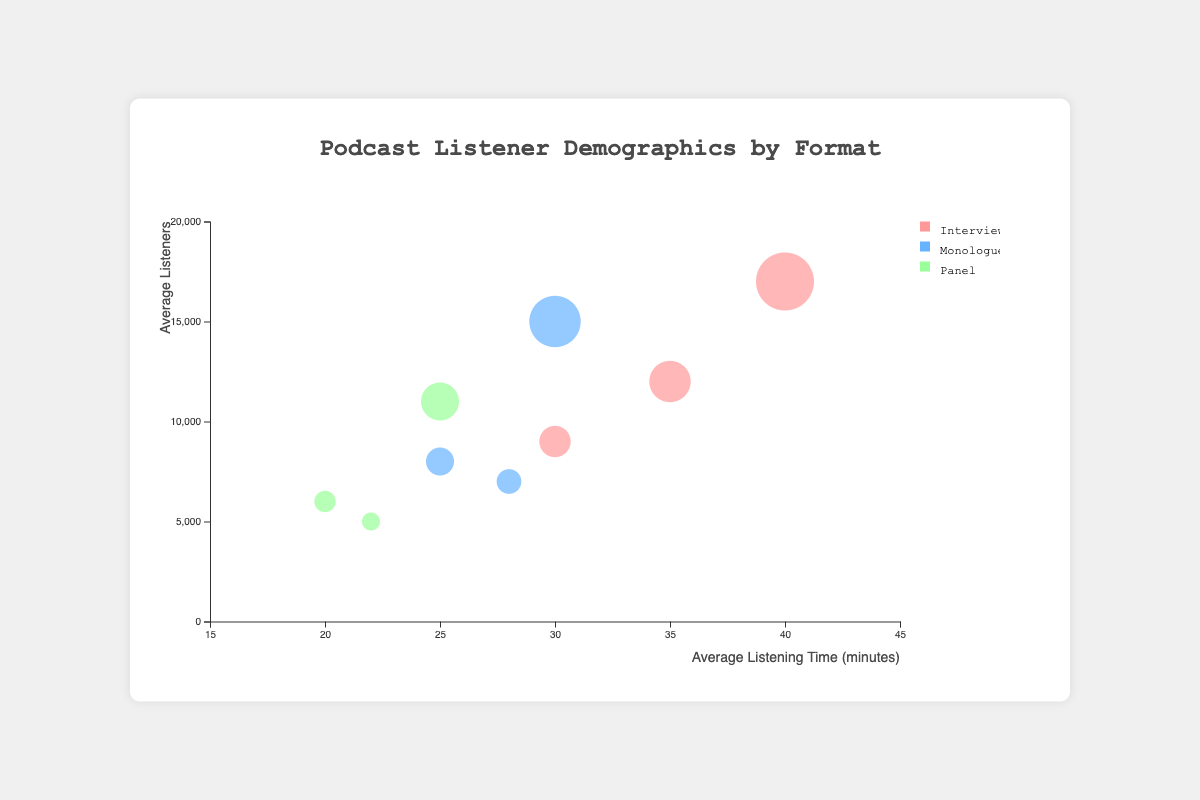What is the title of the chart? The title is displayed at the top of the chart, which reads "Podcast Listener Demographics by Format".
Answer: Podcast Listener Demographics by Format What does the y-axis represent? The y-axis represents the "Average Listeners", as indicated by the label beside the axis.
Answer: Average Listeners Which podcast format has the highest average listeners in the 25-34 age group? By looking at the bubbles for the 25-34 age group, the bubble for "Interview" format is the largest in size and furthest up on the y-axis, indicating it has the highest average listeners.
Answer: Interview What is the average listening time for the Monologue format for the 18-24 age group? Locate the bubble for the Monologue format within the 18-24 age group and observe its position on the x-axis, which corresponds to the average listening time of 25 minutes.
Answer: 25 Which age group listens the longest on average in the Interview format? Among the bubbles for the Interview format, the one representing the 25-34 age group is furthest to the right on the x-axis, indicating the longest average listening time at 40 minutes.
Answer: 25-34 Compare the average listeners for the Monologue format between the 18-24 and 35-44 age groups. Identify the bubbles for the Monologue format for the 18-24 and 35-44 age groups. The 18-24 bubble reaches higher on the y-axis than the 35-44 bubble. Average Listeners: 18-24 is 8000 and 35-44 is 7000.
Answer: 18-24 group has more listeners What is the total average number of listeners for the Interview format? Sum the average listeners for all age groups in the Interview format: 12000 (18-24) + 17000 (25-34) + 9000 (35-44) = 38000.
Answer: 38000 Which podcast format has the smallest average listening time? Examine the bubbles for each format and find the one furthest left. The Panel format in the 18-24 age group has the smallest average listening time at 20 minutes.
Answer: Panel How many podcast formats are represented in the chart? By looking at the color legend on the right-hand side, there are three distinct formats listed: Interview, Monologue, and Panel.
Answer: Three For which age group and format combination is the average listeners count the least? Identify the smallest bubble on the chart and note its position. The Panel format for the 35-44 age group has the smallest bubble, indicating the fewest average listeners, which is 5000 listeners.
Answer: Panel format for the 35-44 age group 